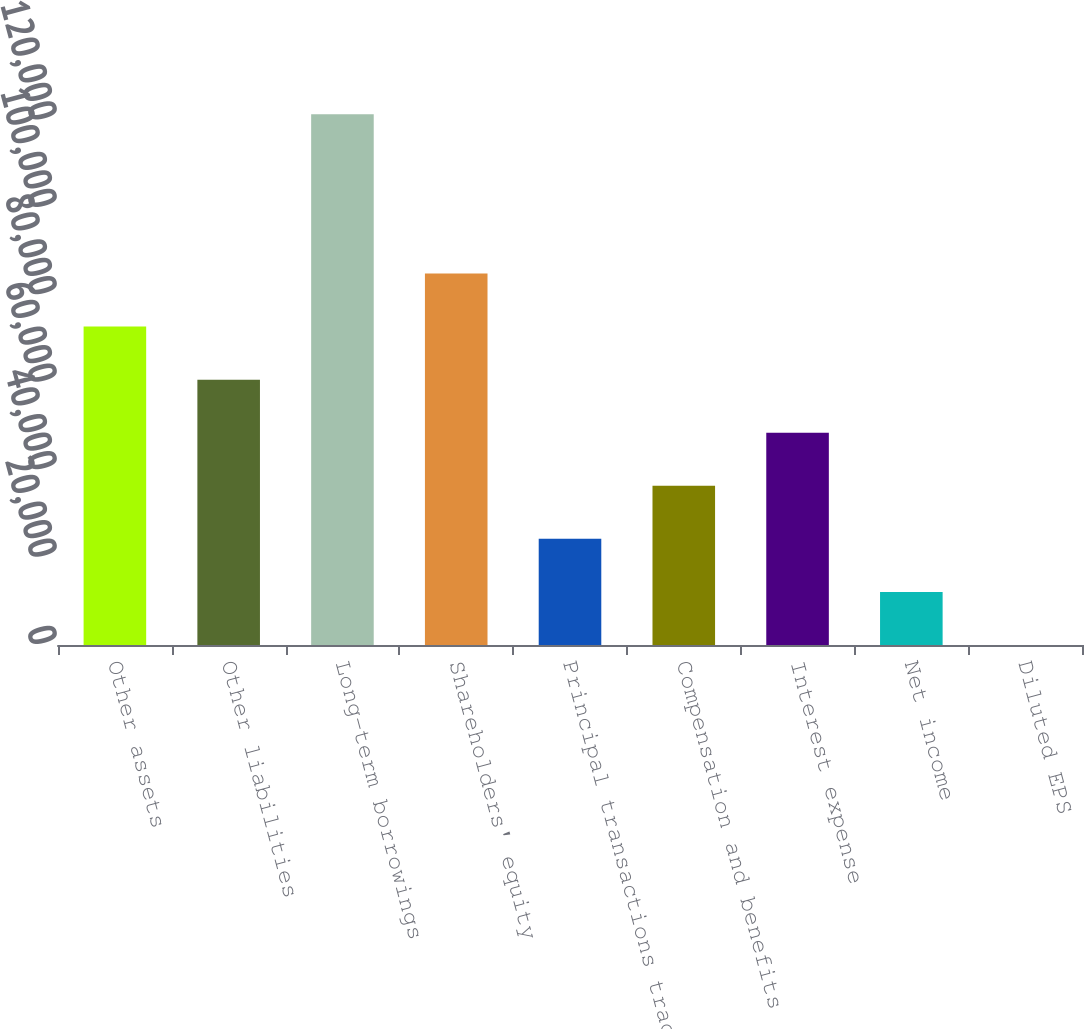Convert chart to OTSL. <chart><loc_0><loc_0><loc_500><loc_500><bar_chart><fcel>Other assets<fcel>Other liabilities<fcel>Long-term borrowings<fcel>Shareholders' equity<fcel>Principal transactions trading<fcel>Compensation and benefits<fcel>Interest expense<fcel>Net income<fcel>Diluted EPS<nl><fcel>72837.6<fcel>60698.2<fcel>121395<fcel>84976.9<fcel>24280.2<fcel>36419.5<fcel>48558.9<fcel>12140.8<fcel>1.47<nl></chart> 